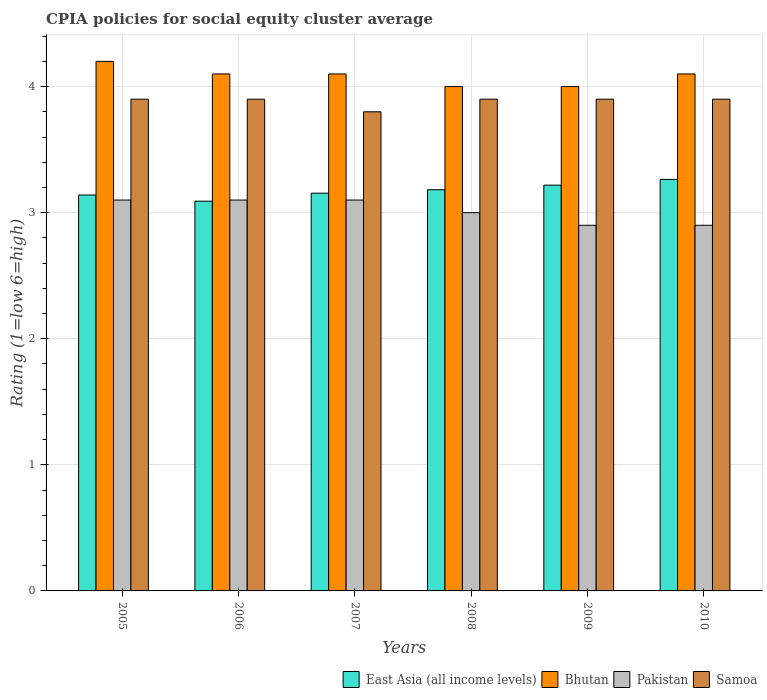How many groups of bars are there?
Give a very brief answer. 6. In how many cases, is the number of bars for a given year not equal to the number of legend labels?
Ensure brevity in your answer.  0. What is the total CPIA rating in Pakistan in the graph?
Your answer should be very brief. 18.1. What is the difference between the CPIA rating in Pakistan in 2007 and that in 2010?
Make the answer very short. 0.2. What is the difference between the CPIA rating in East Asia (all income levels) in 2007 and the CPIA rating in Pakistan in 2009?
Provide a succinct answer. 0.25. What is the average CPIA rating in Pakistan per year?
Provide a succinct answer. 3.02. In the year 2006, what is the difference between the CPIA rating in Samoa and CPIA rating in East Asia (all income levels)?
Your answer should be compact. 0.81. What is the ratio of the CPIA rating in East Asia (all income levels) in 2006 to that in 2007?
Keep it short and to the point. 0.98. Is the difference between the CPIA rating in Samoa in 2005 and 2007 greater than the difference between the CPIA rating in East Asia (all income levels) in 2005 and 2007?
Offer a terse response. Yes. What is the difference between the highest and the second highest CPIA rating in Bhutan?
Keep it short and to the point. 0.1. What is the difference between the highest and the lowest CPIA rating in Pakistan?
Offer a very short reply. 0.2. In how many years, is the CPIA rating in Pakistan greater than the average CPIA rating in Pakistan taken over all years?
Give a very brief answer. 3. What does the 4th bar from the left in 2007 represents?
Provide a succinct answer. Samoa. What does the 4th bar from the right in 2009 represents?
Your answer should be compact. East Asia (all income levels). How many bars are there?
Offer a terse response. 24. Are all the bars in the graph horizontal?
Provide a short and direct response. No. How many years are there in the graph?
Provide a short and direct response. 6. Are the values on the major ticks of Y-axis written in scientific E-notation?
Make the answer very short. No. Does the graph contain any zero values?
Provide a short and direct response. No. Does the graph contain grids?
Offer a terse response. Yes. Where does the legend appear in the graph?
Make the answer very short. Bottom right. How many legend labels are there?
Keep it short and to the point. 4. What is the title of the graph?
Your response must be concise. CPIA policies for social equity cluster average. What is the Rating (1=low 6=high) in East Asia (all income levels) in 2005?
Offer a terse response. 3.14. What is the Rating (1=low 6=high) of East Asia (all income levels) in 2006?
Keep it short and to the point. 3.09. What is the Rating (1=low 6=high) of Pakistan in 2006?
Ensure brevity in your answer.  3.1. What is the Rating (1=low 6=high) in East Asia (all income levels) in 2007?
Keep it short and to the point. 3.15. What is the Rating (1=low 6=high) in Bhutan in 2007?
Your answer should be compact. 4.1. What is the Rating (1=low 6=high) in Samoa in 2007?
Ensure brevity in your answer.  3.8. What is the Rating (1=low 6=high) of East Asia (all income levels) in 2008?
Give a very brief answer. 3.18. What is the Rating (1=low 6=high) of Bhutan in 2008?
Make the answer very short. 4. What is the Rating (1=low 6=high) in Samoa in 2008?
Your response must be concise. 3.9. What is the Rating (1=low 6=high) in East Asia (all income levels) in 2009?
Keep it short and to the point. 3.22. What is the Rating (1=low 6=high) in Bhutan in 2009?
Ensure brevity in your answer.  4. What is the Rating (1=low 6=high) of East Asia (all income levels) in 2010?
Ensure brevity in your answer.  3.26. What is the Rating (1=low 6=high) in Bhutan in 2010?
Provide a succinct answer. 4.1. What is the Rating (1=low 6=high) of Pakistan in 2010?
Provide a succinct answer. 2.9. Across all years, what is the maximum Rating (1=low 6=high) of East Asia (all income levels)?
Your answer should be very brief. 3.26. Across all years, what is the minimum Rating (1=low 6=high) of East Asia (all income levels)?
Offer a terse response. 3.09. Across all years, what is the minimum Rating (1=low 6=high) in Bhutan?
Provide a short and direct response. 4. Across all years, what is the minimum Rating (1=low 6=high) in Pakistan?
Provide a short and direct response. 2.9. What is the total Rating (1=low 6=high) in East Asia (all income levels) in the graph?
Keep it short and to the point. 19.05. What is the total Rating (1=low 6=high) in Bhutan in the graph?
Make the answer very short. 24.5. What is the total Rating (1=low 6=high) in Samoa in the graph?
Provide a short and direct response. 23.3. What is the difference between the Rating (1=low 6=high) in East Asia (all income levels) in 2005 and that in 2006?
Your response must be concise. 0.05. What is the difference between the Rating (1=low 6=high) in Bhutan in 2005 and that in 2006?
Provide a short and direct response. 0.1. What is the difference between the Rating (1=low 6=high) in Pakistan in 2005 and that in 2006?
Ensure brevity in your answer.  0. What is the difference between the Rating (1=low 6=high) in East Asia (all income levels) in 2005 and that in 2007?
Give a very brief answer. -0.01. What is the difference between the Rating (1=low 6=high) in Samoa in 2005 and that in 2007?
Make the answer very short. 0.1. What is the difference between the Rating (1=low 6=high) in East Asia (all income levels) in 2005 and that in 2008?
Your answer should be compact. -0.04. What is the difference between the Rating (1=low 6=high) in Bhutan in 2005 and that in 2008?
Offer a very short reply. 0.2. What is the difference between the Rating (1=low 6=high) of Pakistan in 2005 and that in 2008?
Ensure brevity in your answer.  0.1. What is the difference between the Rating (1=low 6=high) of Samoa in 2005 and that in 2008?
Your answer should be compact. 0. What is the difference between the Rating (1=low 6=high) of East Asia (all income levels) in 2005 and that in 2009?
Your response must be concise. -0.08. What is the difference between the Rating (1=low 6=high) in Bhutan in 2005 and that in 2009?
Your answer should be very brief. 0.2. What is the difference between the Rating (1=low 6=high) of Samoa in 2005 and that in 2009?
Offer a very short reply. 0. What is the difference between the Rating (1=low 6=high) of East Asia (all income levels) in 2005 and that in 2010?
Your response must be concise. -0.12. What is the difference between the Rating (1=low 6=high) in Pakistan in 2005 and that in 2010?
Ensure brevity in your answer.  0.2. What is the difference between the Rating (1=low 6=high) in Samoa in 2005 and that in 2010?
Ensure brevity in your answer.  0. What is the difference between the Rating (1=low 6=high) of East Asia (all income levels) in 2006 and that in 2007?
Your answer should be very brief. -0.06. What is the difference between the Rating (1=low 6=high) in East Asia (all income levels) in 2006 and that in 2008?
Your answer should be compact. -0.09. What is the difference between the Rating (1=low 6=high) of Pakistan in 2006 and that in 2008?
Offer a terse response. 0.1. What is the difference between the Rating (1=low 6=high) of East Asia (all income levels) in 2006 and that in 2009?
Your response must be concise. -0.13. What is the difference between the Rating (1=low 6=high) of Pakistan in 2006 and that in 2009?
Give a very brief answer. 0.2. What is the difference between the Rating (1=low 6=high) in East Asia (all income levels) in 2006 and that in 2010?
Give a very brief answer. -0.17. What is the difference between the Rating (1=low 6=high) in Pakistan in 2006 and that in 2010?
Offer a terse response. 0.2. What is the difference between the Rating (1=low 6=high) in Samoa in 2006 and that in 2010?
Your response must be concise. 0. What is the difference between the Rating (1=low 6=high) of East Asia (all income levels) in 2007 and that in 2008?
Keep it short and to the point. -0.03. What is the difference between the Rating (1=low 6=high) of Samoa in 2007 and that in 2008?
Your answer should be very brief. -0.1. What is the difference between the Rating (1=low 6=high) in East Asia (all income levels) in 2007 and that in 2009?
Give a very brief answer. -0.06. What is the difference between the Rating (1=low 6=high) of Samoa in 2007 and that in 2009?
Your answer should be compact. -0.1. What is the difference between the Rating (1=low 6=high) in East Asia (all income levels) in 2007 and that in 2010?
Make the answer very short. -0.11. What is the difference between the Rating (1=low 6=high) in Bhutan in 2007 and that in 2010?
Offer a terse response. 0. What is the difference between the Rating (1=low 6=high) in Pakistan in 2007 and that in 2010?
Your response must be concise. 0.2. What is the difference between the Rating (1=low 6=high) in Samoa in 2007 and that in 2010?
Give a very brief answer. -0.1. What is the difference between the Rating (1=low 6=high) in East Asia (all income levels) in 2008 and that in 2009?
Offer a very short reply. -0.04. What is the difference between the Rating (1=low 6=high) of Bhutan in 2008 and that in 2009?
Make the answer very short. 0. What is the difference between the Rating (1=low 6=high) in Pakistan in 2008 and that in 2009?
Give a very brief answer. 0.1. What is the difference between the Rating (1=low 6=high) of East Asia (all income levels) in 2008 and that in 2010?
Offer a very short reply. -0.08. What is the difference between the Rating (1=low 6=high) of Bhutan in 2008 and that in 2010?
Your answer should be compact. -0.1. What is the difference between the Rating (1=low 6=high) in Pakistan in 2008 and that in 2010?
Your answer should be compact. 0.1. What is the difference between the Rating (1=low 6=high) in East Asia (all income levels) in 2009 and that in 2010?
Your response must be concise. -0.05. What is the difference between the Rating (1=low 6=high) in Bhutan in 2009 and that in 2010?
Provide a short and direct response. -0.1. What is the difference between the Rating (1=low 6=high) of East Asia (all income levels) in 2005 and the Rating (1=low 6=high) of Bhutan in 2006?
Ensure brevity in your answer.  -0.96. What is the difference between the Rating (1=low 6=high) in East Asia (all income levels) in 2005 and the Rating (1=low 6=high) in Pakistan in 2006?
Your answer should be compact. 0.04. What is the difference between the Rating (1=low 6=high) of East Asia (all income levels) in 2005 and the Rating (1=low 6=high) of Samoa in 2006?
Your answer should be compact. -0.76. What is the difference between the Rating (1=low 6=high) in Bhutan in 2005 and the Rating (1=low 6=high) in Pakistan in 2006?
Offer a very short reply. 1.1. What is the difference between the Rating (1=low 6=high) of Bhutan in 2005 and the Rating (1=low 6=high) of Samoa in 2006?
Provide a succinct answer. 0.3. What is the difference between the Rating (1=low 6=high) in East Asia (all income levels) in 2005 and the Rating (1=low 6=high) in Bhutan in 2007?
Your answer should be compact. -0.96. What is the difference between the Rating (1=low 6=high) of East Asia (all income levels) in 2005 and the Rating (1=low 6=high) of Samoa in 2007?
Your answer should be very brief. -0.66. What is the difference between the Rating (1=low 6=high) of East Asia (all income levels) in 2005 and the Rating (1=low 6=high) of Bhutan in 2008?
Your response must be concise. -0.86. What is the difference between the Rating (1=low 6=high) in East Asia (all income levels) in 2005 and the Rating (1=low 6=high) in Pakistan in 2008?
Offer a very short reply. 0.14. What is the difference between the Rating (1=low 6=high) of East Asia (all income levels) in 2005 and the Rating (1=low 6=high) of Samoa in 2008?
Ensure brevity in your answer.  -0.76. What is the difference between the Rating (1=low 6=high) of Bhutan in 2005 and the Rating (1=low 6=high) of Pakistan in 2008?
Your response must be concise. 1.2. What is the difference between the Rating (1=low 6=high) in Bhutan in 2005 and the Rating (1=low 6=high) in Samoa in 2008?
Offer a terse response. 0.3. What is the difference between the Rating (1=low 6=high) of East Asia (all income levels) in 2005 and the Rating (1=low 6=high) of Bhutan in 2009?
Ensure brevity in your answer.  -0.86. What is the difference between the Rating (1=low 6=high) of East Asia (all income levels) in 2005 and the Rating (1=low 6=high) of Pakistan in 2009?
Your answer should be compact. 0.24. What is the difference between the Rating (1=low 6=high) in East Asia (all income levels) in 2005 and the Rating (1=low 6=high) in Samoa in 2009?
Give a very brief answer. -0.76. What is the difference between the Rating (1=low 6=high) of Pakistan in 2005 and the Rating (1=low 6=high) of Samoa in 2009?
Ensure brevity in your answer.  -0.8. What is the difference between the Rating (1=low 6=high) in East Asia (all income levels) in 2005 and the Rating (1=low 6=high) in Bhutan in 2010?
Offer a very short reply. -0.96. What is the difference between the Rating (1=low 6=high) of East Asia (all income levels) in 2005 and the Rating (1=low 6=high) of Pakistan in 2010?
Give a very brief answer. 0.24. What is the difference between the Rating (1=low 6=high) in East Asia (all income levels) in 2005 and the Rating (1=low 6=high) in Samoa in 2010?
Your answer should be very brief. -0.76. What is the difference between the Rating (1=low 6=high) of Bhutan in 2005 and the Rating (1=low 6=high) of Samoa in 2010?
Your answer should be very brief. 0.3. What is the difference between the Rating (1=low 6=high) of Pakistan in 2005 and the Rating (1=low 6=high) of Samoa in 2010?
Your answer should be very brief. -0.8. What is the difference between the Rating (1=low 6=high) of East Asia (all income levels) in 2006 and the Rating (1=low 6=high) of Bhutan in 2007?
Provide a short and direct response. -1.01. What is the difference between the Rating (1=low 6=high) in East Asia (all income levels) in 2006 and the Rating (1=low 6=high) in Pakistan in 2007?
Provide a succinct answer. -0.01. What is the difference between the Rating (1=low 6=high) in East Asia (all income levels) in 2006 and the Rating (1=low 6=high) in Samoa in 2007?
Provide a succinct answer. -0.71. What is the difference between the Rating (1=low 6=high) in Bhutan in 2006 and the Rating (1=low 6=high) in Samoa in 2007?
Offer a very short reply. 0.3. What is the difference between the Rating (1=low 6=high) of East Asia (all income levels) in 2006 and the Rating (1=low 6=high) of Bhutan in 2008?
Your answer should be compact. -0.91. What is the difference between the Rating (1=low 6=high) of East Asia (all income levels) in 2006 and the Rating (1=low 6=high) of Pakistan in 2008?
Offer a terse response. 0.09. What is the difference between the Rating (1=low 6=high) in East Asia (all income levels) in 2006 and the Rating (1=low 6=high) in Samoa in 2008?
Your answer should be very brief. -0.81. What is the difference between the Rating (1=low 6=high) of East Asia (all income levels) in 2006 and the Rating (1=low 6=high) of Bhutan in 2009?
Keep it short and to the point. -0.91. What is the difference between the Rating (1=low 6=high) of East Asia (all income levels) in 2006 and the Rating (1=low 6=high) of Pakistan in 2009?
Provide a short and direct response. 0.19. What is the difference between the Rating (1=low 6=high) in East Asia (all income levels) in 2006 and the Rating (1=low 6=high) in Samoa in 2009?
Your answer should be compact. -0.81. What is the difference between the Rating (1=low 6=high) of Bhutan in 2006 and the Rating (1=low 6=high) of Samoa in 2009?
Offer a terse response. 0.2. What is the difference between the Rating (1=low 6=high) of East Asia (all income levels) in 2006 and the Rating (1=low 6=high) of Bhutan in 2010?
Provide a short and direct response. -1.01. What is the difference between the Rating (1=low 6=high) in East Asia (all income levels) in 2006 and the Rating (1=low 6=high) in Pakistan in 2010?
Your answer should be compact. 0.19. What is the difference between the Rating (1=low 6=high) of East Asia (all income levels) in 2006 and the Rating (1=low 6=high) of Samoa in 2010?
Ensure brevity in your answer.  -0.81. What is the difference between the Rating (1=low 6=high) in Bhutan in 2006 and the Rating (1=low 6=high) in Pakistan in 2010?
Give a very brief answer. 1.2. What is the difference between the Rating (1=low 6=high) in Pakistan in 2006 and the Rating (1=low 6=high) in Samoa in 2010?
Your response must be concise. -0.8. What is the difference between the Rating (1=low 6=high) in East Asia (all income levels) in 2007 and the Rating (1=low 6=high) in Bhutan in 2008?
Provide a succinct answer. -0.85. What is the difference between the Rating (1=low 6=high) of East Asia (all income levels) in 2007 and the Rating (1=low 6=high) of Pakistan in 2008?
Your answer should be very brief. 0.15. What is the difference between the Rating (1=low 6=high) in East Asia (all income levels) in 2007 and the Rating (1=low 6=high) in Samoa in 2008?
Give a very brief answer. -0.75. What is the difference between the Rating (1=low 6=high) of Pakistan in 2007 and the Rating (1=low 6=high) of Samoa in 2008?
Provide a succinct answer. -0.8. What is the difference between the Rating (1=low 6=high) of East Asia (all income levels) in 2007 and the Rating (1=low 6=high) of Bhutan in 2009?
Keep it short and to the point. -0.85. What is the difference between the Rating (1=low 6=high) of East Asia (all income levels) in 2007 and the Rating (1=low 6=high) of Pakistan in 2009?
Your answer should be very brief. 0.25. What is the difference between the Rating (1=low 6=high) in East Asia (all income levels) in 2007 and the Rating (1=low 6=high) in Samoa in 2009?
Your response must be concise. -0.75. What is the difference between the Rating (1=low 6=high) in Bhutan in 2007 and the Rating (1=low 6=high) in Samoa in 2009?
Provide a succinct answer. 0.2. What is the difference between the Rating (1=low 6=high) in East Asia (all income levels) in 2007 and the Rating (1=low 6=high) in Bhutan in 2010?
Offer a terse response. -0.95. What is the difference between the Rating (1=low 6=high) in East Asia (all income levels) in 2007 and the Rating (1=low 6=high) in Pakistan in 2010?
Your answer should be very brief. 0.25. What is the difference between the Rating (1=low 6=high) of East Asia (all income levels) in 2007 and the Rating (1=low 6=high) of Samoa in 2010?
Ensure brevity in your answer.  -0.75. What is the difference between the Rating (1=low 6=high) in Pakistan in 2007 and the Rating (1=low 6=high) in Samoa in 2010?
Your answer should be very brief. -0.8. What is the difference between the Rating (1=low 6=high) in East Asia (all income levels) in 2008 and the Rating (1=low 6=high) in Bhutan in 2009?
Provide a succinct answer. -0.82. What is the difference between the Rating (1=low 6=high) in East Asia (all income levels) in 2008 and the Rating (1=low 6=high) in Pakistan in 2009?
Your answer should be very brief. 0.28. What is the difference between the Rating (1=low 6=high) of East Asia (all income levels) in 2008 and the Rating (1=low 6=high) of Samoa in 2009?
Offer a very short reply. -0.72. What is the difference between the Rating (1=low 6=high) of Bhutan in 2008 and the Rating (1=low 6=high) of Samoa in 2009?
Your answer should be very brief. 0.1. What is the difference between the Rating (1=low 6=high) of East Asia (all income levels) in 2008 and the Rating (1=low 6=high) of Bhutan in 2010?
Keep it short and to the point. -0.92. What is the difference between the Rating (1=low 6=high) in East Asia (all income levels) in 2008 and the Rating (1=low 6=high) in Pakistan in 2010?
Provide a succinct answer. 0.28. What is the difference between the Rating (1=low 6=high) in East Asia (all income levels) in 2008 and the Rating (1=low 6=high) in Samoa in 2010?
Provide a short and direct response. -0.72. What is the difference between the Rating (1=low 6=high) of Bhutan in 2008 and the Rating (1=low 6=high) of Pakistan in 2010?
Give a very brief answer. 1.1. What is the difference between the Rating (1=low 6=high) in East Asia (all income levels) in 2009 and the Rating (1=low 6=high) in Bhutan in 2010?
Provide a short and direct response. -0.88. What is the difference between the Rating (1=low 6=high) in East Asia (all income levels) in 2009 and the Rating (1=low 6=high) in Pakistan in 2010?
Keep it short and to the point. 0.32. What is the difference between the Rating (1=low 6=high) in East Asia (all income levels) in 2009 and the Rating (1=low 6=high) in Samoa in 2010?
Ensure brevity in your answer.  -0.68. What is the difference between the Rating (1=low 6=high) in Bhutan in 2009 and the Rating (1=low 6=high) in Pakistan in 2010?
Make the answer very short. 1.1. What is the difference between the Rating (1=low 6=high) of Bhutan in 2009 and the Rating (1=low 6=high) of Samoa in 2010?
Make the answer very short. 0.1. What is the difference between the Rating (1=low 6=high) of Pakistan in 2009 and the Rating (1=low 6=high) of Samoa in 2010?
Provide a short and direct response. -1. What is the average Rating (1=low 6=high) in East Asia (all income levels) per year?
Ensure brevity in your answer.  3.17. What is the average Rating (1=low 6=high) in Bhutan per year?
Provide a succinct answer. 4.08. What is the average Rating (1=low 6=high) of Pakistan per year?
Your answer should be compact. 3.02. What is the average Rating (1=low 6=high) in Samoa per year?
Provide a short and direct response. 3.88. In the year 2005, what is the difference between the Rating (1=low 6=high) in East Asia (all income levels) and Rating (1=low 6=high) in Bhutan?
Your answer should be very brief. -1.06. In the year 2005, what is the difference between the Rating (1=low 6=high) in East Asia (all income levels) and Rating (1=low 6=high) in Pakistan?
Ensure brevity in your answer.  0.04. In the year 2005, what is the difference between the Rating (1=low 6=high) in East Asia (all income levels) and Rating (1=low 6=high) in Samoa?
Give a very brief answer. -0.76. In the year 2005, what is the difference between the Rating (1=low 6=high) of Bhutan and Rating (1=low 6=high) of Pakistan?
Give a very brief answer. 1.1. In the year 2005, what is the difference between the Rating (1=low 6=high) in Bhutan and Rating (1=low 6=high) in Samoa?
Your answer should be compact. 0.3. In the year 2005, what is the difference between the Rating (1=low 6=high) of Pakistan and Rating (1=low 6=high) of Samoa?
Offer a very short reply. -0.8. In the year 2006, what is the difference between the Rating (1=low 6=high) in East Asia (all income levels) and Rating (1=low 6=high) in Bhutan?
Offer a terse response. -1.01. In the year 2006, what is the difference between the Rating (1=low 6=high) in East Asia (all income levels) and Rating (1=low 6=high) in Pakistan?
Your answer should be compact. -0.01. In the year 2006, what is the difference between the Rating (1=low 6=high) in East Asia (all income levels) and Rating (1=low 6=high) in Samoa?
Offer a terse response. -0.81. In the year 2006, what is the difference between the Rating (1=low 6=high) of Bhutan and Rating (1=low 6=high) of Samoa?
Your answer should be compact. 0.2. In the year 2006, what is the difference between the Rating (1=low 6=high) of Pakistan and Rating (1=low 6=high) of Samoa?
Make the answer very short. -0.8. In the year 2007, what is the difference between the Rating (1=low 6=high) in East Asia (all income levels) and Rating (1=low 6=high) in Bhutan?
Keep it short and to the point. -0.95. In the year 2007, what is the difference between the Rating (1=low 6=high) in East Asia (all income levels) and Rating (1=low 6=high) in Pakistan?
Your response must be concise. 0.05. In the year 2007, what is the difference between the Rating (1=low 6=high) in East Asia (all income levels) and Rating (1=low 6=high) in Samoa?
Your response must be concise. -0.65. In the year 2007, what is the difference between the Rating (1=low 6=high) in Bhutan and Rating (1=low 6=high) in Pakistan?
Provide a succinct answer. 1. In the year 2008, what is the difference between the Rating (1=low 6=high) of East Asia (all income levels) and Rating (1=low 6=high) of Bhutan?
Provide a short and direct response. -0.82. In the year 2008, what is the difference between the Rating (1=low 6=high) in East Asia (all income levels) and Rating (1=low 6=high) in Pakistan?
Offer a terse response. 0.18. In the year 2008, what is the difference between the Rating (1=low 6=high) of East Asia (all income levels) and Rating (1=low 6=high) of Samoa?
Give a very brief answer. -0.72. In the year 2008, what is the difference between the Rating (1=low 6=high) of Bhutan and Rating (1=low 6=high) of Pakistan?
Provide a succinct answer. 1. In the year 2008, what is the difference between the Rating (1=low 6=high) in Bhutan and Rating (1=low 6=high) in Samoa?
Provide a short and direct response. 0.1. In the year 2009, what is the difference between the Rating (1=low 6=high) in East Asia (all income levels) and Rating (1=low 6=high) in Bhutan?
Ensure brevity in your answer.  -0.78. In the year 2009, what is the difference between the Rating (1=low 6=high) in East Asia (all income levels) and Rating (1=low 6=high) in Pakistan?
Offer a very short reply. 0.32. In the year 2009, what is the difference between the Rating (1=low 6=high) of East Asia (all income levels) and Rating (1=low 6=high) of Samoa?
Offer a terse response. -0.68. In the year 2009, what is the difference between the Rating (1=low 6=high) of Bhutan and Rating (1=low 6=high) of Samoa?
Provide a succinct answer. 0.1. In the year 2010, what is the difference between the Rating (1=low 6=high) of East Asia (all income levels) and Rating (1=low 6=high) of Bhutan?
Keep it short and to the point. -0.84. In the year 2010, what is the difference between the Rating (1=low 6=high) of East Asia (all income levels) and Rating (1=low 6=high) of Pakistan?
Offer a very short reply. 0.36. In the year 2010, what is the difference between the Rating (1=low 6=high) of East Asia (all income levels) and Rating (1=low 6=high) of Samoa?
Offer a very short reply. -0.64. In the year 2010, what is the difference between the Rating (1=low 6=high) of Bhutan and Rating (1=low 6=high) of Pakistan?
Your answer should be compact. 1.2. What is the ratio of the Rating (1=low 6=high) in East Asia (all income levels) in 2005 to that in 2006?
Provide a succinct answer. 1.02. What is the ratio of the Rating (1=low 6=high) in Bhutan in 2005 to that in 2006?
Offer a terse response. 1.02. What is the ratio of the Rating (1=low 6=high) in Bhutan in 2005 to that in 2007?
Ensure brevity in your answer.  1.02. What is the ratio of the Rating (1=low 6=high) in Pakistan in 2005 to that in 2007?
Offer a very short reply. 1. What is the ratio of the Rating (1=low 6=high) of Samoa in 2005 to that in 2007?
Make the answer very short. 1.03. What is the ratio of the Rating (1=low 6=high) in East Asia (all income levels) in 2005 to that in 2008?
Provide a short and direct response. 0.99. What is the ratio of the Rating (1=low 6=high) in Pakistan in 2005 to that in 2008?
Offer a terse response. 1.03. What is the ratio of the Rating (1=low 6=high) in Samoa in 2005 to that in 2008?
Your answer should be very brief. 1. What is the ratio of the Rating (1=low 6=high) of East Asia (all income levels) in 2005 to that in 2009?
Your answer should be compact. 0.98. What is the ratio of the Rating (1=low 6=high) of Bhutan in 2005 to that in 2009?
Give a very brief answer. 1.05. What is the ratio of the Rating (1=low 6=high) in Pakistan in 2005 to that in 2009?
Offer a terse response. 1.07. What is the ratio of the Rating (1=low 6=high) in Samoa in 2005 to that in 2009?
Your answer should be compact. 1. What is the ratio of the Rating (1=low 6=high) of East Asia (all income levels) in 2005 to that in 2010?
Make the answer very short. 0.96. What is the ratio of the Rating (1=low 6=high) of Bhutan in 2005 to that in 2010?
Give a very brief answer. 1.02. What is the ratio of the Rating (1=low 6=high) of Pakistan in 2005 to that in 2010?
Ensure brevity in your answer.  1.07. What is the ratio of the Rating (1=low 6=high) of Samoa in 2005 to that in 2010?
Provide a short and direct response. 1. What is the ratio of the Rating (1=low 6=high) of East Asia (all income levels) in 2006 to that in 2007?
Offer a terse response. 0.98. What is the ratio of the Rating (1=low 6=high) in Bhutan in 2006 to that in 2007?
Provide a succinct answer. 1. What is the ratio of the Rating (1=low 6=high) of Samoa in 2006 to that in 2007?
Keep it short and to the point. 1.03. What is the ratio of the Rating (1=low 6=high) of East Asia (all income levels) in 2006 to that in 2008?
Ensure brevity in your answer.  0.97. What is the ratio of the Rating (1=low 6=high) of Bhutan in 2006 to that in 2008?
Provide a short and direct response. 1.02. What is the ratio of the Rating (1=low 6=high) of East Asia (all income levels) in 2006 to that in 2009?
Ensure brevity in your answer.  0.96. What is the ratio of the Rating (1=low 6=high) in Pakistan in 2006 to that in 2009?
Offer a very short reply. 1.07. What is the ratio of the Rating (1=low 6=high) in East Asia (all income levels) in 2006 to that in 2010?
Your answer should be very brief. 0.95. What is the ratio of the Rating (1=low 6=high) in Bhutan in 2006 to that in 2010?
Keep it short and to the point. 1. What is the ratio of the Rating (1=low 6=high) in Pakistan in 2006 to that in 2010?
Your answer should be very brief. 1.07. What is the ratio of the Rating (1=low 6=high) of Bhutan in 2007 to that in 2008?
Provide a succinct answer. 1.02. What is the ratio of the Rating (1=low 6=high) in Samoa in 2007 to that in 2008?
Your answer should be very brief. 0.97. What is the ratio of the Rating (1=low 6=high) of East Asia (all income levels) in 2007 to that in 2009?
Your answer should be compact. 0.98. What is the ratio of the Rating (1=low 6=high) of Bhutan in 2007 to that in 2009?
Make the answer very short. 1.02. What is the ratio of the Rating (1=low 6=high) of Pakistan in 2007 to that in 2009?
Provide a succinct answer. 1.07. What is the ratio of the Rating (1=low 6=high) of Samoa in 2007 to that in 2009?
Keep it short and to the point. 0.97. What is the ratio of the Rating (1=low 6=high) of East Asia (all income levels) in 2007 to that in 2010?
Offer a very short reply. 0.97. What is the ratio of the Rating (1=low 6=high) of Bhutan in 2007 to that in 2010?
Your response must be concise. 1. What is the ratio of the Rating (1=low 6=high) in Pakistan in 2007 to that in 2010?
Your answer should be compact. 1.07. What is the ratio of the Rating (1=low 6=high) in Samoa in 2007 to that in 2010?
Provide a succinct answer. 0.97. What is the ratio of the Rating (1=low 6=high) in East Asia (all income levels) in 2008 to that in 2009?
Your response must be concise. 0.99. What is the ratio of the Rating (1=low 6=high) of Pakistan in 2008 to that in 2009?
Give a very brief answer. 1.03. What is the ratio of the Rating (1=low 6=high) in Samoa in 2008 to that in 2009?
Your response must be concise. 1. What is the ratio of the Rating (1=low 6=high) of East Asia (all income levels) in 2008 to that in 2010?
Your answer should be compact. 0.97. What is the ratio of the Rating (1=low 6=high) in Bhutan in 2008 to that in 2010?
Provide a succinct answer. 0.98. What is the ratio of the Rating (1=low 6=high) in Pakistan in 2008 to that in 2010?
Provide a short and direct response. 1.03. What is the ratio of the Rating (1=low 6=high) of East Asia (all income levels) in 2009 to that in 2010?
Make the answer very short. 0.99. What is the ratio of the Rating (1=low 6=high) of Bhutan in 2009 to that in 2010?
Provide a succinct answer. 0.98. What is the ratio of the Rating (1=low 6=high) of Pakistan in 2009 to that in 2010?
Make the answer very short. 1. What is the ratio of the Rating (1=low 6=high) of Samoa in 2009 to that in 2010?
Your answer should be compact. 1. What is the difference between the highest and the second highest Rating (1=low 6=high) in East Asia (all income levels)?
Your response must be concise. 0.05. What is the difference between the highest and the second highest Rating (1=low 6=high) of Pakistan?
Make the answer very short. 0. What is the difference between the highest and the second highest Rating (1=low 6=high) of Samoa?
Your answer should be compact. 0. What is the difference between the highest and the lowest Rating (1=low 6=high) in East Asia (all income levels)?
Offer a terse response. 0.17. 